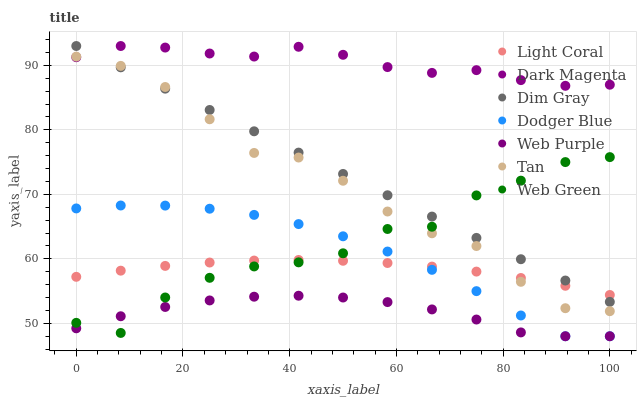Does Web Purple have the minimum area under the curve?
Answer yes or no. Yes. Does Dark Magenta have the maximum area under the curve?
Answer yes or no. Yes. Does Web Green have the minimum area under the curve?
Answer yes or no. No. Does Web Green have the maximum area under the curve?
Answer yes or no. No. Is Dim Gray the smoothest?
Answer yes or no. Yes. Is Web Green the roughest?
Answer yes or no. Yes. Is Dark Magenta the smoothest?
Answer yes or no. No. Is Dark Magenta the roughest?
Answer yes or no. No. Does Web Purple have the lowest value?
Answer yes or no. Yes. Does Web Green have the lowest value?
Answer yes or no. No. Does Dark Magenta have the highest value?
Answer yes or no. Yes. Does Web Green have the highest value?
Answer yes or no. No. Is Dodger Blue less than Dim Gray?
Answer yes or no. Yes. Is Dark Magenta greater than Light Coral?
Answer yes or no. Yes. Does Web Green intersect Tan?
Answer yes or no. Yes. Is Web Green less than Tan?
Answer yes or no. No. Is Web Green greater than Tan?
Answer yes or no. No. Does Dodger Blue intersect Dim Gray?
Answer yes or no. No. 